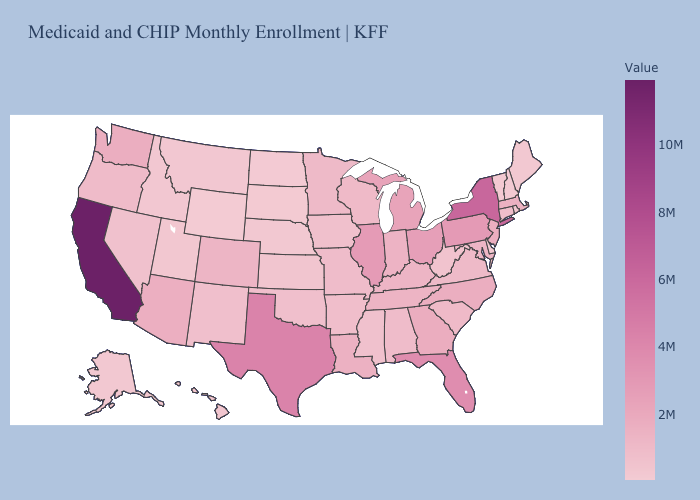Does Rhode Island have the highest value in the Northeast?
Keep it brief. No. Among the states that border New Jersey , does Delaware have the highest value?
Quick response, please. No. Does New Hampshire have the highest value in the Northeast?
Be succinct. No. Which states have the highest value in the USA?
Be succinct. California. Which states have the lowest value in the MidWest?
Be succinct. North Dakota. Does Wyoming have the lowest value in the USA?
Be succinct. Yes. Does New Jersey have the highest value in the Northeast?
Answer briefly. No. Does the map have missing data?
Concise answer only. No. Does New York have the highest value in the Northeast?
Answer briefly. Yes. Does Utah have a lower value than New Jersey?
Concise answer only. Yes. 